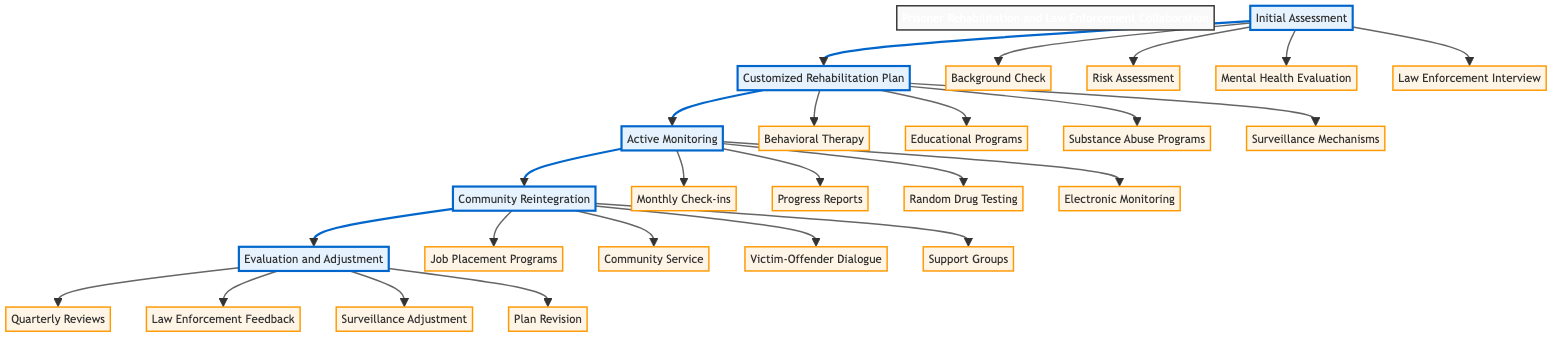What is the first stage in the pathway? The diagram clearly identifies "Initial Assessment" as the first stage, indicated by its position at the beginning of the flow.
Answer: Initial Assessment How many components are in the "Active Monitoring" stage? By examining the "Active Monitoring" stage in the diagram, I see it has four listed components: Monthly Check-ins, Progress Reports, Random Drug Testing, and Electronic Monitoring.
Answer: 4 What is assessed during the "Initial Assessment"? The components in the "Initial Assessment" stage outline that a Background Check, Risk Assessment using COMPAS, Mental Health Evaluation, and Law Enforcement Interview are conducted to evaluate prisoners' profiles.
Answer: Background Check, Risk Assessment using COMPAS, Mental Health Evaluation, Law Enforcement Interview Which stage includes "Job Placement Programs"? The diagram associates "Job Placement Programs" with the "Community Reintegration" stage, showing that this component falls under the support provided during the reintegration process into society.
Answer: Community Reintegration How does the "Customized Rehabilitation Plan" relate to the "Evaluation and Adjustment" stage? The "Customized Rehabilitation Plan" feeds into the "Evaluation and Adjustment" stage as it is important that the rehabilitation plan is reviewed and adjusted regularly based on the feedback from law enforcement and other components.
Answer: It feeds into the next stage for review What feedback is gathered during "Evaluation and Adjustment"? The components show that feedback from law enforcement officers is collected, along with quarterly reviews, to evaluate the effectiveness of the rehabilitation plan.
Answer: Feedback from Law Enforcement Officers Which surveillance mechanisms are mentioned in the "Customized Rehabilitation Plan"? I can see that the surveillance mechanisms in this stage include GPS Monitoring, which is listed among the components aimed at ensuring compliance with the rehabilitation plan.
Answer: GPS Monitoring What is the purpose of "Community Service Requirements"? Analyzing the diagram, the "Community Service Requirements" in the "Community Reintegration" stage serve to engage prisoners in productive activities that contribute positively to society and aid in their reintegration process.
Answer: To engage prisoners positively with society How often are "Quarterly Reviews" conducted in the process? The term "Quarterly Reviews" appears in the "Evaluation and Adjustment" stage, indicating that reviews occur four times within a year to assess and make necessary adjustments to rehabilitation plans.
Answer: Quarterly (four times a year) 